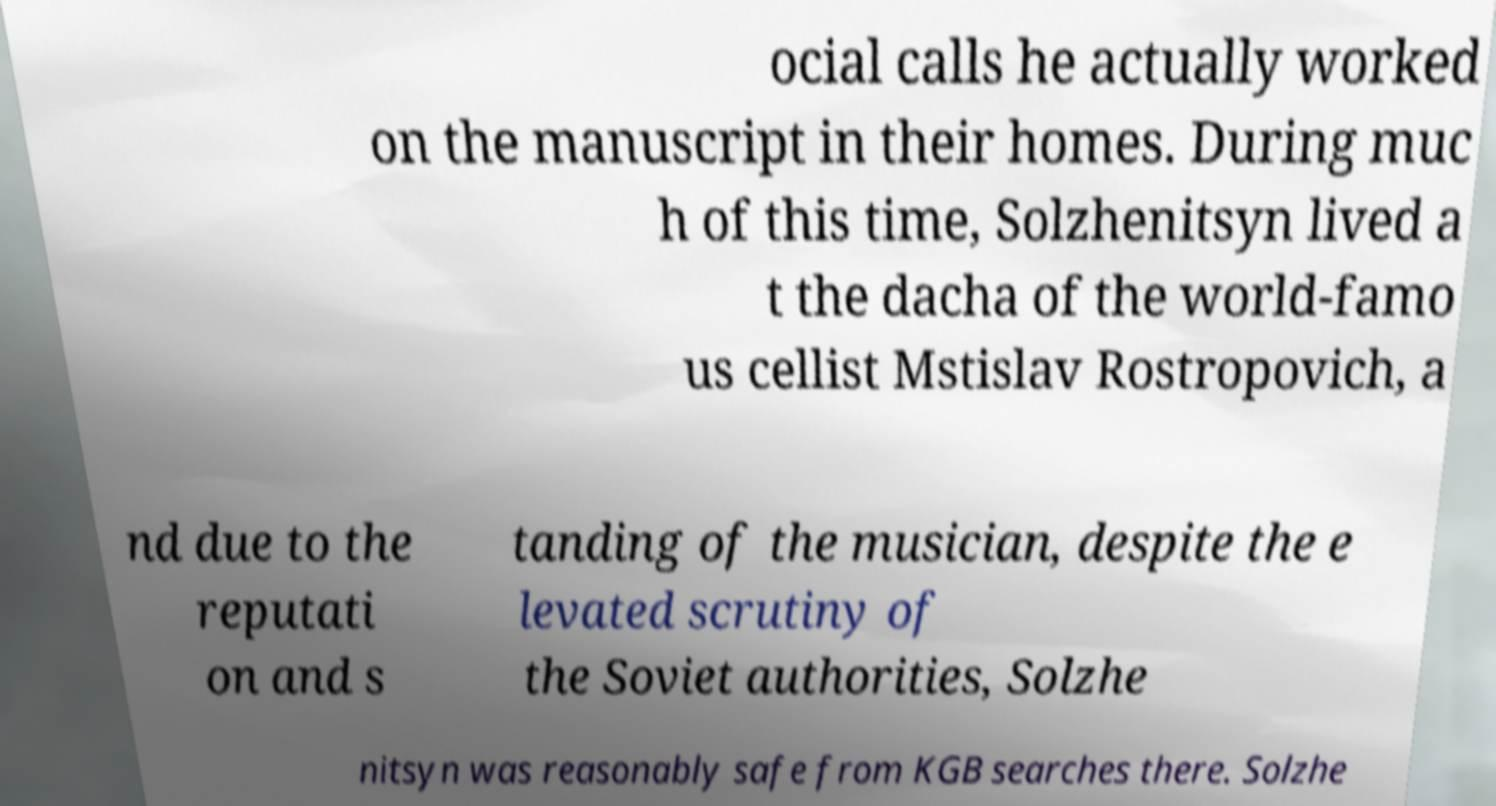What messages or text are displayed in this image? I need them in a readable, typed format. ocial calls he actually worked on the manuscript in their homes. During muc h of this time, Solzhenitsyn lived a t the dacha of the world-famo us cellist Mstislav Rostropovich, a nd due to the reputati on and s tanding of the musician, despite the e levated scrutiny of the Soviet authorities, Solzhe nitsyn was reasonably safe from KGB searches there. Solzhe 